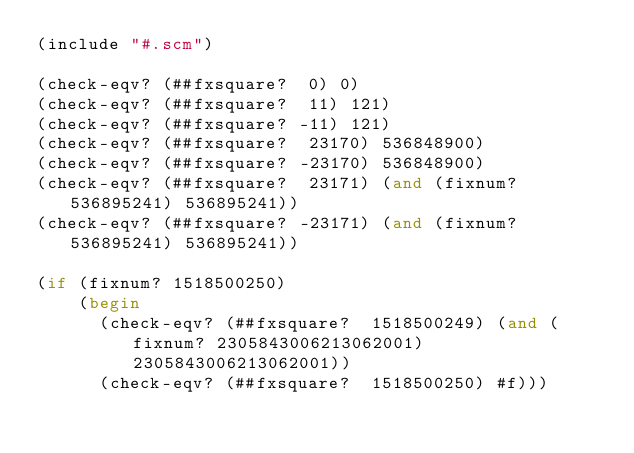<code> <loc_0><loc_0><loc_500><loc_500><_Scheme_>(include "#.scm")

(check-eqv? (##fxsquare?  0) 0)
(check-eqv? (##fxsquare?  11) 121)
(check-eqv? (##fxsquare? -11) 121)
(check-eqv? (##fxsquare?  23170) 536848900)
(check-eqv? (##fxsquare? -23170) 536848900)
(check-eqv? (##fxsquare?  23171) (and (fixnum? 536895241) 536895241))
(check-eqv? (##fxsquare? -23171) (and (fixnum? 536895241) 536895241))

(if (fixnum? 1518500250)
    (begin
      (check-eqv? (##fxsquare?  1518500249) (and (fixnum? 2305843006213062001) 2305843006213062001))
      (check-eqv? (##fxsquare?  1518500250) #f)))
</code> 